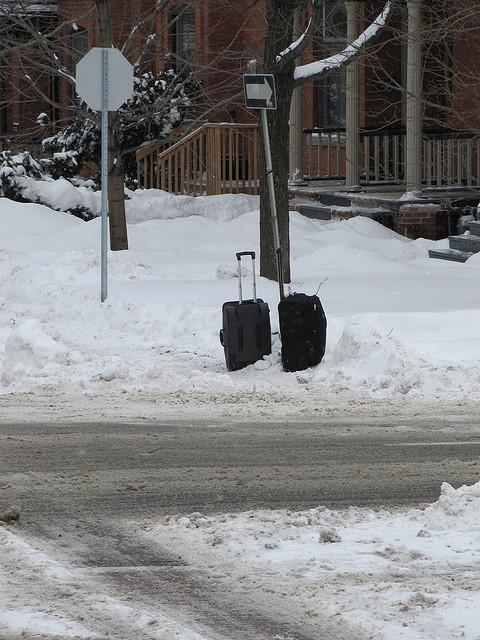How many people are in this image?
Give a very brief answer. 0. How many suitcases are in the photo?
Give a very brief answer. 2. 